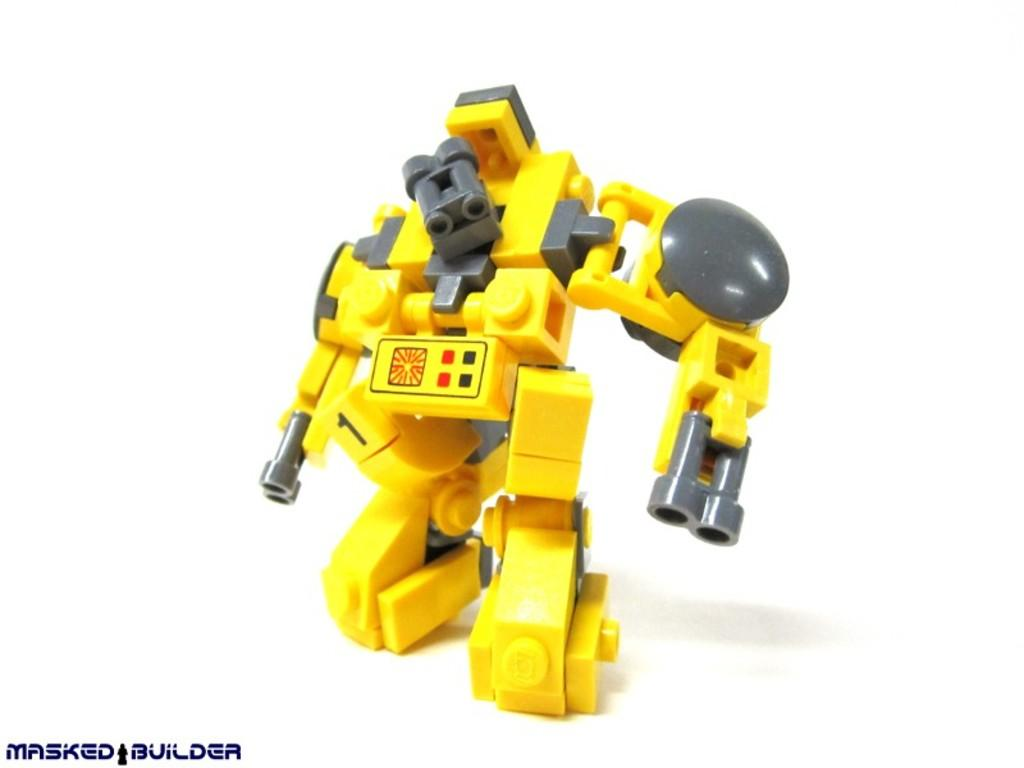What object can be seen in the image that is not related to text? There is a toy in the image. Where is the text located in the image? The text is in the bottom left corner of the image. How many boats are visible in the image? There are no boats present in the image. What is the opinion of the toy in the image? The image does not convey an opinion about the toy; it simply shows the toy's presence. 